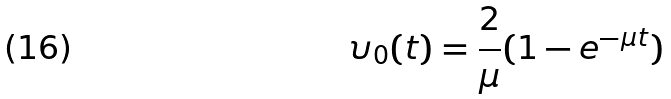Convert formula to latex. <formula><loc_0><loc_0><loc_500><loc_500>\upsilon _ { 0 } ( t ) = \frac { 2 } { \mu } ( 1 - e ^ { - \mu t } )</formula> 